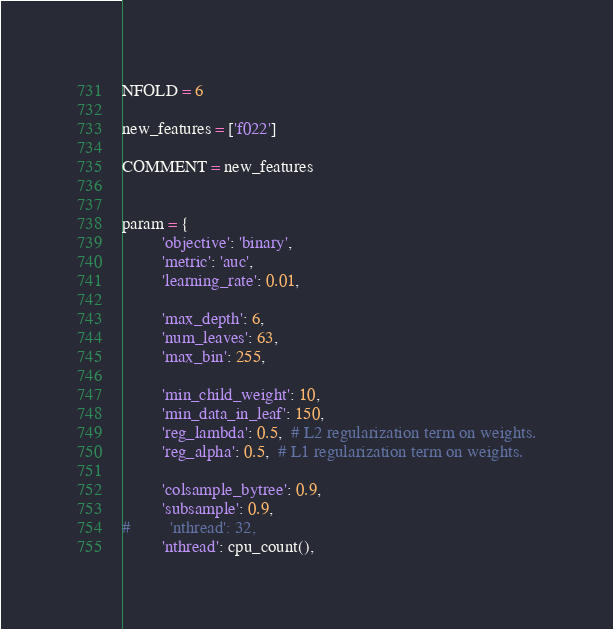<code> <loc_0><loc_0><loc_500><loc_500><_Python_>NFOLD = 6

new_features = ['f022']

COMMENT = new_features


param = {
         'objective': 'binary',
         'metric': 'auc',
         'learning_rate': 0.01,
         
         'max_depth': 6,
         'num_leaves': 63,
         'max_bin': 255,
         
         'min_child_weight': 10,
         'min_data_in_leaf': 150,
         'reg_lambda': 0.5,  # L2 regularization term on weights.
         'reg_alpha': 0.5,  # L1 regularization term on weights.
         
         'colsample_bytree': 0.9,
         'subsample': 0.9,
#         'nthread': 32,
         'nthread': cpu_count(),</code> 